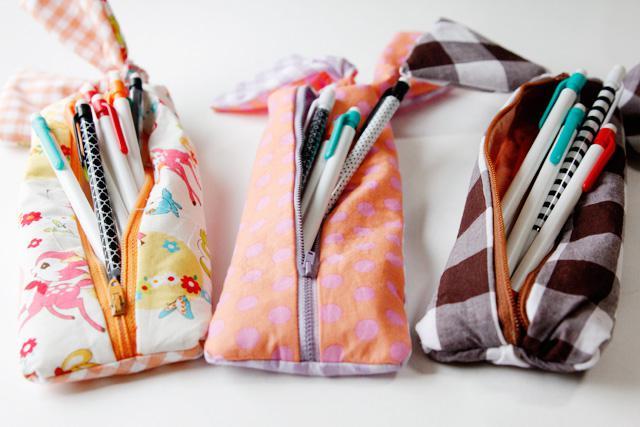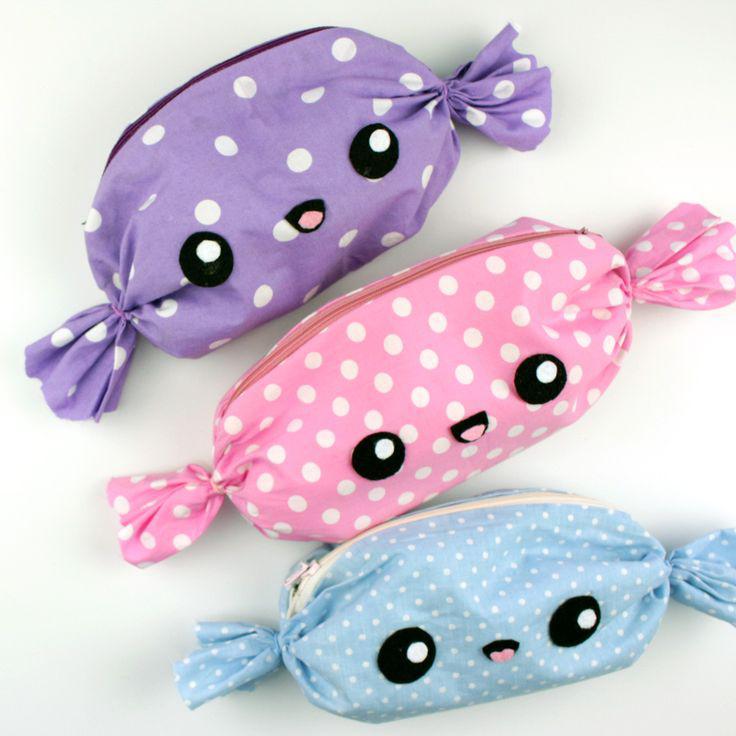The first image is the image on the left, the second image is the image on the right. Analyze the images presented: Is the assertion "All the pencil cases feature animal-inspired shapes." valid? Answer yes or no. No. 